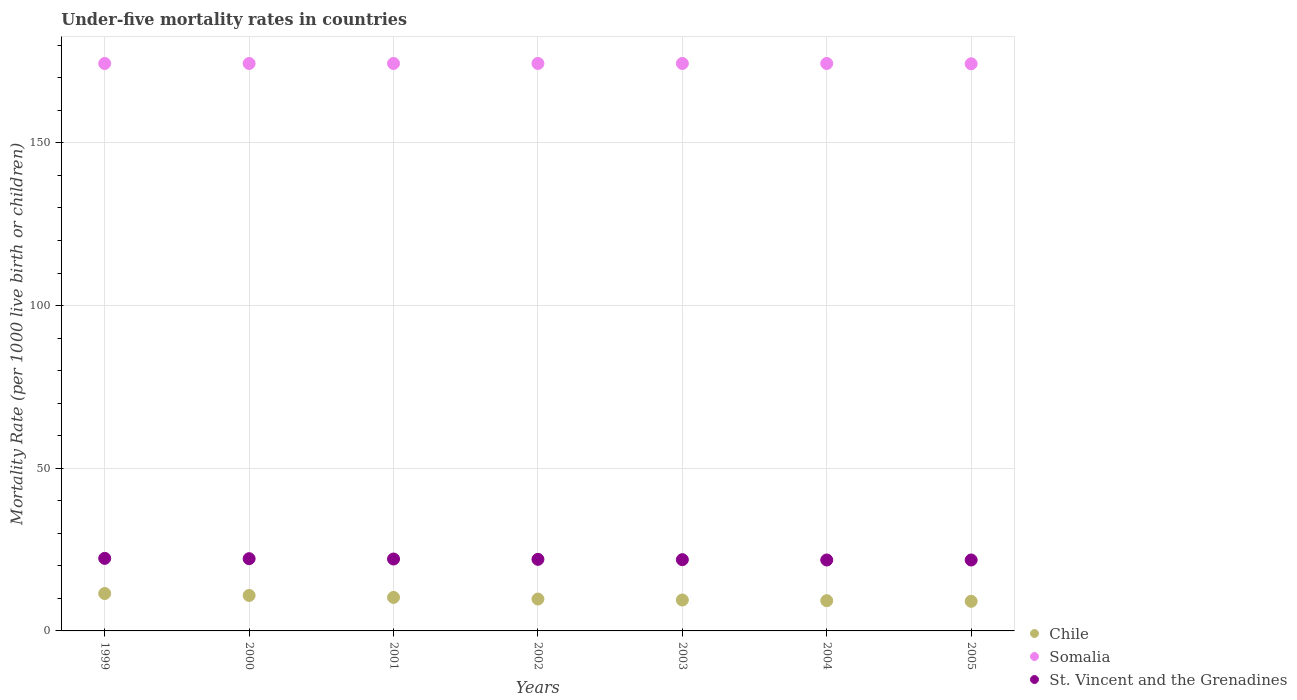How many different coloured dotlines are there?
Your answer should be compact. 3. Across all years, what is the maximum under-five mortality rate in St. Vincent and the Grenadines?
Make the answer very short. 22.3. Across all years, what is the minimum under-five mortality rate in Chile?
Offer a terse response. 9.1. In which year was the under-five mortality rate in Somalia maximum?
Make the answer very short. 1999. What is the total under-five mortality rate in St. Vincent and the Grenadines in the graph?
Give a very brief answer. 154.1. What is the difference between the under-five mortality rate in Chile in 2000 and that in 2001?
Keep it short and to the point. 0.6. What is the difference between the under-five mortality rate in Chile in 1999 and the under-five mortality rate in St. Vincent and the Grenadines in 2001?
Give a very brief answer. -10.6. What is the average under-five mortality rate in Chile per year?
Provide a succinct answer. 10.06. In the year 2004, what is the difference between the under-five mortality rate in Somalia and under-five mortality rate in St. Vincent and the Grenadines?
Offer a very short reply. 152.6. What is the difference between the highest and the second highest under-five mortality rate in St. Vincent and the Grenadines?
Give a very brief answer. 0.1. What is the difference between the highest and the lowest under-five mortality rate in Chile?
Offer a terse response. 2.4. In how many years, is the under-five mortality rate in St. Vincent and the Grenadines greater than the average under-five mortality rate in St. Vincent and the Grenadines taken over all years?
Provide a succinct answer. 3. Does the under-five mortality rate in Chile monotonically increase over the years?
Keep it short and to the point. No. Is the under-five mortality rate in Somalia strictly greater than the under-five mortality rate in Chile over the years?
Offer a very short reply. Yes. How many dotlines are there?
Make the answer very short. 3. How many years are there in the graph?
Your answer should be compact. 7. Does the graph contain grids?
Ensure brevity in your answer.  Yes. Where does the legend appear in the graph?
Offer a very short reply. Bottom right. What is the title of the graph?
Your response must be concise. Under-five mortality rates in countries. What is the label or title of the Y-axis?
Provide a succinct answer. Mortality Rate (per 1000 live birth or children). What is the Mortality Rate (per 1000 live birth or children) of Chile in 1999?
Provide a succinct answer. 11.5. What is the Mortality Rate (per 1000 live birth or children) of Somalia in 1999?
Make the answer very short. 174.4. What is the Mortality Rate (per 1000 live birth or children) of St. Vincent and the Grenadines in 1999?
Your response must be concise. 22.3. What is the Mortality Rate (per 1000 live birth or children) of Somalia in 2000?
Ensure brevity in your answer.  174.4. What is the Mortality Rate (per 1000 live birth or children) in St. Vincent and the Grenadines in 2000?
Ensure brevity in your answer.  22.2. What is the Mortality Rate (per 1000 live birth or children) in Somalia in 2001?
Offer a very short reply. 174.4. What is the Mortality Rate (per 1000 live birth or children) in St. Vincent and the Grenadines in 2001?
Your response must be concise. 22.1. What is the Mortality Rate (per 1000 live birth or children) in Chile in 2002?
Give a very brief answer. 9.8. What is the Mortality Rate (per 1000 live birth or children) in Somalia in 2002?
Your answer should be compact. 174.4. What is the Mortality Rate (per 1000 live birth or children) of St. Vincent and the Grenadines in 2002?
Your response must be concise. 22. What is the Mortality Rate (per 1000 live birth or children) in Chile in 2003?
Provide a short and direct response. 9.5. What is the Mortality Rate (per 1000 live birth or children) of Somalia in 2003?
Offer a terse response. 174.4. What is the Mortality Rate (per 1000 live birth or children) in St. Vincent and the Grenadines in 2003?
Keep it short and to the point. 21.9. What is the Mortality Rate (per 1000 live birth or children) of Chile in 2004?
Keep it short and to the point. 9.3. What is the Mortality Rate (per 1000 live birth or children) of Somalia in 2004?
Give a very brief answer. 174.4. What is the Mortality Rate (per 1000 live birth or children) of St. Vincent and the Grenadines in 2004?
Give a very brief answer. 21.8. What is the Mortality Rate (per 1000 live birth or children) of Chile in 2005?
Make the answer very short. 9.1. What is the Mortality Rate (per 1000 live birth or children) in Somalia in 2005?
Your answer should be very brief. 174.3. What is the Mortality Rate (per 1000 live birth or children) in St. Vincent and the Grenadines in 2005?
Your response must be concise. 21.8. Across all years, what is the maximum Mortality Rate (per 1000 live birth or children) of Chile?
Provide a succinct answer. 11.5. Across all years, what is the maximum Mortality Rate (per 1000 live birth or children) in Somalia?
Ensure brevity in your answer.  174.4. Across all years, what is the maximum Mortality Rate (per 1000 live birth or children) of St. Vincent and the Grenadines?
Offer a very short reply. 22.3. Across all years, what is the minimum Mortality Rate (per 1000 live birth or children) in Chile?
Provide a short and direct response. 9.1. Across all years, what is the minimum Mortality Rate (per 1000 live birth or children) of Somalia?
Offer a very short reply. 174.3. Across all years, what is the minimum Mortality Rate (per 1000 live birth or children) of St. Vincent and the Grenadines?
Offer a very short reply. 21.8. What is the total Mortality Rate (per 1000 live birth or children) of Chile in the graph?
Your answer should be very brief. 70.4. What is the total Mortality Rate (per 1000 live birth or children) of Somalia in the graph?
Your answer should be very brief. 1220.7. What is the total Mortality Rate (per 1000 live birth or children) in St. Vincent and the Grenadines in the graph?
Your response must be concise. 154.1. What is the difference between the Mortality Rate (per 1000 live birth or children) of Somalia in 1999 and that in 2000?
Offer a very short reply. 0. What is the difference between the Mortality Rate (per 1000 live birth or children) in St. Vincent and the Grenadines in 1999 and that in 2000?
Keep it short and to the point. 0.1. What is the difference between the Mortality Rate (per 1000 live birth or children) of Chile in 1999 and that in 2001?
Your response must be concise. 1.2. What is the difference between the Mortality Rate (per 1000 live birth or children) of Somalia in 1999 and that in 2002?
Give a very brief answer. 0. What is the difference between the Mortality Rate (per 1000 live birth or children) in Chile in 1999 and that in 2004?
Provide a short and direct response. 2.2. What is the difference between the Mortality Rate (per 1000 live birth or children) of Somalia in 1999 and that in 2004?
Offer a very short reply. 0. What is the difference between the Mortality Rate (per 1000 live birth or children) in St. Vincent and the Grenadines in 1999 and that in 2004?
Your response must be concise. 0.5. What is the difference between the Mortality Rate (per 1000 live birth or children) of Somalia in 1999 and that in 2005?
Your answer should be compact. 0.1. What is the difference between the Mortality Rate (per 1000 live birth or children) in St. Vincent and the Grenadines in 1999 and that in 2005?
Your answer should be compact. 0.5. What is the difference between the Mortality Rate (per 1000 live birth or children) of Chile in 2000 and that in 2001?
Give a very brief answer. 0.6. What is the difference between the Mortality Rate (per 1000 live birth or children) of St. Vincent and the Grenadines in 2000 and that in 2001?
Offer a terse response. 0.1. What is the difference between the Mortality Rate (per 1000 live birth or children) of Chile in 2000 and that in 2002?
Offer a very short reply. 1.1. What is the difference between the Mortality Rate (per 1000 live birth or children) in Somalia in 2000 and that in 2002?
Make the answer very short. 0. What is the difference between the Mortality Rate (per 1000 live birth or children) of Somalia in 2000 and that in 2003?
Offer a terse response. 0. What is the difference between the Mortality Rate (per 1000 live birth or children) of Chile in 2000 and that in 2004?
Your response must be concise. 1.6. What is the difference between the Mortality Rate (per 1000 live birth or children) in Somalia in 2000 and that in 2004?
Your response must be concise. 0. What is the difference between the Mortality Rate (per 1000 live birth or children) of St. Vincent and the Grenadines in 2000 and that in 2004?
Your answer should be very brief. 0.4. What is the difference between the Mortality Rate (per 1000 live birth or children) of Chile in 2000 and that in 2005?
Give a very brief answer. 1.8. What is the difference between the Mortality Rate (per 1000 live birth or children) of Somalia in 2000 and that in 2005?
Give a very brief answer. 0.1. What is the difference between the Mortality Rate (per 1000 live birth or children) of Somalia in 2001 and that in 2002?
Ensure brevity in your answer.  0. What is the difference between the Mortality Rate (per 1000 live birth or children) of St. Vincent and the Grenadines in 2001 and that in 2002?
Offer a very short reply. 0.1. What is the difference between the Mortality Rate (per 1000 live birth or children) in Chile in 2001 and that in 2003?
Offer a terse response. 0.8. What is the difference between the Mortality Rate (per 1000 live birth or children) in Somalia in 2001 and that in 2005?
Ensure brevity in your answer.  0.1. What is the difference between the Mortality Rate (per 1000 live birth or children) of St. Vincent and the Grenadines in 2001 and that in 2005?
Keep it short and to the point. 0.3. What is the difference between the Mortality Rate (per 1000 live birth or children) in Chile in 2002 and that in 2003?
Ensure brevity in your answer.  0.3. What is the difference between the Mortality Rate (per 1000 live birth or children) in Somalia in 2002 and that in 2003?
Ensure brevity in your answer.  0. What is the difference between the Mortality Rate (per 1000 live birth or children) in Somalia in 2002 and that in 2004?
Give a very brief answer. 0. What is the difference between the Mortality Rate (per 1000 live birth or children) in St. Vincent and the Grenadines in 2002 and that in 2004?
Keep it short and to the point. 0.2. What is the difference between the Mortality Rate (per 1000 live birth or children) of Somalia in 2002 and that in 2005?
Provide a short and direct response. 0.1. What is the difference between the Mortality Rate (per 1000 live birth or children) of St. Vincent and the Grenadines in 2002 and that in 2005?
Ensure brevity in your answer.  0.2. What is the difference between the Mortality Rate (per 1000 live birth or children) of Chile in 2003 and that in 2004?
Make the answer very short. 0.2. What is the difference between the Mortality Rate (per 1000 live birth or children) of Somalia in 2003 and that in 2004?
Make the answer very short. 0. What is the difference between the Mortality Rate (per 1000 live birth or children) of St. Vincent and the Grenadines in 2003 and that in 2004?
Provide a short and direct response. 0.1. What is the difference between the Mortality Rate (per 1000 live birth or children) of Somalia in 2003 and that in 2005?
Offer a very short reply. 0.1. What is the difference between the Mortality Rate (per 1000 live birth or children) in Chile in 2004 and that in 2005?
Offer a very short reply. 0.2. What is the difference between the Mortality Rate (per 1000 live birth or children) in St. Vincent and the Grenadines in 2004 and that in 2005?
Give a very brief answer. 0. What is the difference between the Mortality Rate (per 1000 live birth or children) in Chile in 1999 and the Mortality Rate (per 1000 live birth or children) in Somalia in 2000?
Your answer should be compact. -162.9. What is the difference between the Mortality Rate (per 1000 live birth or children) of Somalia in 1999 and the Mortality Rate (per 1000 live birth or children) of St. Vincent and the Grenadines in 2000?
Provide a short and direct response. 152.2. What is the difference between the Mortality Rate (per 1000 live birth or children) of Chile in 1999 and the Mortality Rate (per 1000 live birth or children) of Somalia in 2001?
Give a very brief answer. -162.9. What is the difference between the Mortality Rate (per 1000 live birth or children) in Somalia in 1999 and the Mortality Rate (per 1000 live birth or children) in St. Vincent and the Grenadines in 2001?
Ensure brevity in your answer.  152.3. What is the difference between the Mortality Rate (per 1000 live birth or children) of Chile in 1999 and the Mortality Rate (per 1000 live birth or children) of Somalia in 2002?
Offer a very short reply. -162.9. What is the difference between the Mortality Rate (per 1000 live birth or children) of Somalia in 1999 and the Mortality Rate (per 1000 live birth or children) of St. Vincent and the Grenadines in 2002?
Your answer should be compact. 152.4. What is the difference between the Mortality Rate (per 1000 live birth or children) of Chile in 1999 and the Mortality Rate (per 1000 live birth or children) of Somalia in 2003?
Provide a short and direct response. -162.9. What is the difference between the Mortality Rate (per 1000 live birth or children) of Somalia in 1999 and the Mortality Rate (per 1000 live birth or children) of St. Vincent and the Grenadines in 2003?
Ensure brevity in your answer.  152.5. What is the difference between the Mortality Rate (per 1000 live birth or children) in Chile in 1999 and the Mortality Rate (per 1000 live birth or children) in Somalia in 2004?
Offer a terse response. -162.9. What is the difference between the Mortality Rate (per 1000 live birth or children) in Somalia in 1999 and the Mortality Rate (per 1000 live birth or children) in St. Vincent and the Grenadines in 2004?
Offer a terse response. 152.6. What is the difference between the Mortality Rate (per 1000 live birth or children) in Chile in 1999 and the Mortality Rate (per 1000 live birth or children) in Somalia in 2005?
Give a very brief answer. -162.8. What is the difference between the Mortality Rate (per 1000 live birth or children) in Chile in 1999 and the Mortality Rate (per 1000 live birth or children) in St. Vincent and the Grenadines in 2005?
Offer a very short reply. -10.3. What is the difference between the Mortality Rate (per 1000 live birth or children) in Somalia in 1999 and the Mortality Rate (per 1000 live birth or children) in St. Vincent and the Grenadines in 2005?
Make the answer very short. 152.6. What is the difference between the Mortality Rate (per 1000 live birth or children) in Chile in 2000 and the Mortality Rate (per 1000 live birth or children) in Somalia in 2001?
Your response must be concise. -163.5. What is the difference between the Mortality Rate (per 1000 live birth or children) in Chile in 2000 and the Mortality Rate (per 1000 live birth or children) in St. Vincent and the Grenadines in 2001?
Your answer should be compact. -11.2. What is the difference between the Mortality Rate (per 1000 live birth or children) of Somalia in 2000 and the Mortality Rate (per 1000 live birth or children) of St. Vincent and the Grenadines in 2001?
Ensure brevity in your answer.  152.3. What is the difference between the Mortality Rate (per 1000 live birth or children) of Chile in 2000 and the Mortality Rate (per 1000 live birth or children) of Somalia in 2002?
Offer a terse response. -163.5. What is the difference between the Mortality Rate (per 1000 live birth or children) of Chile in 2000 and the Mortality Rate (per 1000 live birth or children) of St. Vincent and the Grenadines in 2002?
Make the answer very short. -11.1. What is the difference between the Mortality Rate (per 1000 live birth or children) of Somalia in 2000 and the Mortality Rate (per 1000 live birth or children) of St. Vincent and the Grenadines in 2002?
Offer a terse response. 152.4. What is the difference between the Mortality Rate (per 1000 live birth or children) in Chile in 2000 and the Mortality Rate (per 1000 live birth or children) in Somalia in 2003?
Your response must be concise. -163.5. What is the difference between the Mortality Rate (per 1000 live birth or children) of Chile in 2000 and the Mortality Rate (per 1000 live birth or children) of St. Vincent and the Grenadines in 2003?
Your answer should be compact. -11. What is the difference between the Mortality Rate (per 1000 live birth or children) in Somalia in 2000 and the Mortality Rate (per 1000 live birth or children) in St. Vincent and the Grenadines in 2003?
Offer a very short reply. 152.5. What is the difference between the Mortality Rate (per 1000 live birth or children) of Chile in 2000 and the Mortality Rate (per 1000 live birth or children) of Somalia in 2004?
Provide a succinct answer. -163.5. What is the difference between the Mortality Rate (per 1000 live birth or children) in Chile in 2000 and the Mortality Rate (per 1000 live birth or children) in St. Vincent and the Grenadines in 2004?
Ensure brevity in your answer.  -10.9. What is the difference between the Mortality Rate (per 1000 live birth or children) in Somalia in 2000 and the Mortality Rate (per 1000 live birth or children) in St. Vincent and the Grenadines in 2004?
Offer a terse response. 152.6. What is the difference between the Mortality Rate (per 1000 live birth or children) in Chile in 2000 and the Mortality Rate (per 1000 live birth or children) in Somalia in 2005?
Offer a very short reply. -163.4. What is the difference between the Mortality Rate (per 1000 live birth or children) in Chile in 2000 and the Mortality Rate (per 1000 live birth or children) in St. Vincent and the Grenadines in 2005?
Ensure brevity in your answer.  -10.9. What is the difference between the Mortality Rate (per 1000 live birth or children) in Somalia in 2000 and the Mortality Rate (per 1000 live birth or children) in St. Vincent and the Grenadines in 2005?
Give a very brief answer. 152.6. What is the difference between the Mortality Rate (per 1000 live birth or children) in Chile in 2001 and the Mortality Rate (per 1000 live birth or children) in Somalia in 2002?
Keep it short and to the point. -164.1. What is the difference between the Mortality Rate (per 1000 live birth or children) in Somalia in 2001 and the Mortality Rate (per 1000 live birth or children) in St. Vincent and the Grenadines in 2002?
Keep it short and to the point. 152.4. What is the difference between the Mortality Rate (per 1000 live birth or children) of Chile in 2001 and the Mortality Rate (per 1000 live birth or children) of Somalia in 2003?
Make the answer very short. -164.1. What is the difference between the Mortality Rate (per 1000 live birth or children) in Chile in 2001 and the Mortality Rate (per 1000 live birth or children) in St. Vincent and the Grenadines in 2003?
Offer a terse response. -11.6. What is the difference between the Mortality Rate (per 1000 live birth or children) of Somalia in 2001 and the Mortality Rate (per 1000 live birth or children) of St. Vincent and the Grenadines in 2003?
Your answer should be very brief. 152.5. What is the difference between the Mortality Rate (per 1000 live birth or children) in Chile in 2001 and the Mortality Rate (per 1000 live birth or children) in Somalia in 2004?
Keep it short and to the point. -164.1. What is the difference between the Mortality Rate (per 1000 live birth or children) of Somalia in 2001 and the Mortality Rate (per 1000 live birth or children) of St. Vincent and the Grenadines in 2004?
Give a very brief answer. 152.6. What is the difference between the Mortality Rate (per 1000 live birth or children) of Chile in 2001 and the Mortality Rate (per 1000 live birth or children) of Somalia in 2005?
Provide a short and direct response. -164. What is the difference between the Mortality Rate (per 1000 live birth or children) of Somalia in 2001 and the Mortality Rate (per 1000 live birth or children) of St. Vincent and the Grenadines in 2005?
Keep it short and to the point. 152.6. What is the difference between the Mortality Rate (per 1000 live birth or children) in Chile in 2002 and the Mortality Rate (per 1000 live birth or children) in Somalia in 2003?
Your answer should be very brief. -164.6. What is the difference between the Mortality Rate (per 1000 live birth or children) in Chile in 2002 and the Mortality Rate (per 1000 live birth or children) in St. Vincent and the Grenadines in 2003?
Your response must be concise. -12.1. What is the difference between the Mortality Rate (per 1000 live birth or children) in Somalia in 2002 and the Mortality Rate (per 1000 live birth or children) in St. Vincent and the Grenadines in 2003?
Provide a succinct answer. 152.5. What is the difference between the Mortality Rate (per 1000 live birth or children) in Chile in 2002 and the Mortality Rate (per 1000 live birth or children) in Somalia in 2004?
Keep it short and to the point. -164.6. What is the difference between the Mortality Rate (per 1000 live birth or children) in Somalia in 2002 and the Mortality Rate (per 1000 live birth or children) in St. Vincent and the Grenadines in 2004?
Provide a short and direct response. 152.6. What is the difference between the Mortality Rate (per 1000 live birth or children) in Chile in 2002 and the Mortality Rate (per 1000 live birth or children) in Somalia in 2005?
Provide a succinct answer. -164.5. What is the difference between the Mortality Rate (per 1000 live birth or children) of Chile in 2002 and the Mortality Rate (per 1000 live birth or children) of St. Vincent and the Grenadines in 2005?
Make the answer very short. -12. What is the difference between the Mortality Rate (per 1000 live birth or children) in Somalia in 2002 and the Mortality Rate (per 1000 live birth or children) in St. Vincent and the Grenadines in 2005?
Provide a short and direct response. 152.6. What is the difference between the Mortality Rate (per 1000 live birth or children) of Chile in 2003 and the Mortality Rate (per 1000 live birth or children) of Somalia in 2004?
Your answer should be compact. -164.9. What is the difference between the Mortality Rate (per 1000 live birth or children) in Somalia in 2003 and the Mortality Rate (per 1000 live birth or children) in St. Vincent and the Grenadines in 2004?
Keep it short and to the point. 152.6. What is the difference between the Mortality Rate (per 1000 live birth or children) in Chile in 2003 and the Mortality Rate (per 1000 live birth or children) in Somalia in 2005?
Offer a very short reply. -164.8. What is the difference between the Mortality Rate (per 1000 live birth or children) of Chile in 2003 and the Mortality Rate (per 1000 live birth or children) of St. Vincent and the Grenadines in 2005?
Ensure brevity in your answer.  -12.3. What is the difference between the Mortality Rate (per 1000 live birth or children) in Somalia in 2003 and the Mortality Rate (per 1000 live birth or children) in St. Vincent and the Grenadines in 2005?
Offer a terse response. 152.6. What is the difference between the Mortality Rate (per 1000 live birth or children) in Chile in 2004 and the Mortality Rate (per 1000 live birth or children) in Somalia in 2005?
Your response must be concise. -165. What is the difference between the Mortality Rate (per 1000 live birth or children) in Somalia in 2004 and the Mortality Rate (per 1000 live birth or children) in St. Vincent and the Grenadines in 2005?
Provide a succinct answer. 152.6. What is the average Mortality Rate (per 1000 live birth or children) in Chile per year?
Make the answer very short. 10.06. What is the average Mortality Rate (per 1000 live birth or children) of Somalia per year?
Offer a terse response. 174.39. What is the average Mortality Rate (per 1000 live birth or children) of St. Vincent and the Grenadines per year?
Your answer should be very brief. 22.01. In the year 1999, what is the difference between the Mortality Rate (per 1000 live birth or children) in Chile and Mortality Rate (per 1000 live birth or children) in Somalia?
Keep it short and to the point. -162.9. In the year 1999, what is the difference between the Mortality Rate (per 1000 live birth or children) in Chile and Mortality Rate (per 1000 live birth or children) in St. Vincent and the Grenadines?
Your answer should be compact. -10.8. In the year 1999, what is the difference between the Mortality Rate (per 1000 live birth or children) in Somalia and Mortality Rate (per 1000 live birth or children) in St. Vincent and the Grenadines?
Your answer should be compact. 152.1. In the year 2000, what is the difference between the Mortality Rate (per 1000 live birth or children) in Chile and Mortality Rate (per 1000 live birth or children) in Somalia?
Ensure brevity in your answer.  -163.5. In the year 2000, what is the difference between the Mortality Rate (per 1000 live birth or children) of Chile and Mortality Rate (per 1000 live birth or children) of St. Vincent and the Grenadines?
Your answer should be compact. -11.3. In the year 2000, what is the difference between the Mortality Rate (per 1000 live birth or children) in Somalia and Mortality Rate (per 1000 live birth or children) in St. Vincent and the Grenadines?
Keep it short and to the point. 152.2. In the year 2001, what is the difference between the Mortality Rate (per 1000 live birth or children) of Chile and Mortality Rate (per 1000 live birth or children) of Somalia?
Make the answer very short. -164.1. In the year 2001, what is the difference between the Mortality Rate (per 1000 live birth or children) of Chile and Mortality Rate (per 1000 live birth or children) of St. Vincent and the Grenadines?
Keep it short and to the point. -11.8. In the year 2001, what is the difference between the Mortality Rate (per 1000 live birth or children) in Somalia and Mortality Rate (per 1000 live birth or children) in St. Vincent and the Grenadines?
Offer a very short reply. 152.3. In the year 2002, what is the difference between the Mortality Rate (per 1000 live birth or children) of Chile and Mortality Rate (per 1000 live birth or children) of Somalia?
Give a very brief answer. -164.6. In the year 2002, what is the difference between the Mortality Rate (per 1000 live birth or children) of Somalia and Mortality Rate (per 1000 live birth or children) of St. Vincent and the Grenadines?
Make the answer very short. 152.4. In the year 2003, what is the difference between the Mortality Rate (per 1000 live birth or children) in Chile and Mortality Rate (per 1000 live birth or children) in Somalia?
Your answer should be compact. -164.9. In the year 2003, what is the difference between the Mortality Rate (per 1000 live birth or children) in Chile and Mortality Rate (per 1000 live birth or children) in St. Vincent and the Grenadines?
Keep it short and to the point. -12.4. In the year 2003, what is the difference between the Mortality Rate (per 1000 live birth or children) in Somalia and Mortality Rate (per 1000 live birth or children) in St. Vincent and the Grenadines?
Your answer should be compact. 152.5. In the year 2004, what is the difference between the Mortality Rate (per 1000 live birth or children) of Chile and Mortality Rate (per 1000 live birth or children) of Somalia?
Make the answer very short. -165.1. In the year 2004, what is the difference between the Mortality Rate (per 1000 live birth or children) of Chile and Mortality Rate (per 1000 live birth or children) of St. Vincent and the Grenadines?
Make the answer very short. -12.5. In the year 2004, what is the difference between the Mortality Rate (per 1000 live birth or children) in Somalia and Mortality Rate (per 1000 live birth or children) in St. Vincent and the Grenadines?
Provide a succinct answer. 152.6. In the year 2005, what is the difference between the Mortality Rate (per 1000 live birth or children) in Chile and Mortality Rate (per 1000 live birth or children) in Somalia?
Your response must be concise. -165.2. In the year 2005, what is the difference between the Mortality Rate (per 1000 live birth or children) of Somalia and Mortality Rate (per 1000 live birth or children) of St. Vincent and the Grenadines?
Keep it short and to the point. 152.5. What is the ratio of the Mortality Rate (per 1000 live birth or children) of Chile in 1999 to that in 2000?
Provide a short and direct response. 1.05. What is the ratio of the Mortality Rate (per 1000 live birth or children) in St. Vincent and the Grenadines in 1999 to that in 2000?
Give a very brief answer. 1. What is the ratio of the Mortality Rate (per 1000 live birth or children) in Chile in 1999 to that in 2001?
Your answer should be very brief. 1.12. What is the ratio of the Mortality Rate (per 1000 live birth or children) in Somalia in 1999 to that in 2001?
Offer a very short reply. 1. What is the ratio of the Mortality Rate (per 1000 live birth or children) of Chile in 1999 to that in 2002?
Keep it short and to the point. 1.17. What is the ratio of the Mortality Rate (per 1000 live birth or children) of St. Vincent and the Grenadines in 1999 to that in 2002?
Give a very brief answer. 1.01. What is the ratio of the Mortality Rate (per 1000 live birth or children) in Chile in 1999 to that in 2003?
Make the answer very short. 1.21. What is the ratio of the Mortality Rate (per 1000 live birth or children) in Somalia in 1999 to that in 2003?
Your response must be concise. 1. What is the ratio of the Mortality Rate (per 1000 live birth or children) of St. Vincent and the Grenadines in 1999 to that in 2003?
Your answer should be compact. 1.02. What is the ratio of the Mortality Rate (per 1000 live birth or children) of Chile in 1999 to that in 2004?
Your answer should be very brief. 1.24. What is the ratio of the Mortality Rate (per 1000 live birth or children) of Somalia in 1999 to that in 2004?
Offer a terse response. 1. What is the ratio of the Mortality Rate (per 1000 live birth or children) in St. Vincent and the Grenadines in 1999 to that in 2004?
Your answer should be very brief. 1.02. What is the ratio of the Mortality Rate (per 1000 live birth or children) of Chile in 1999 to that in 2005?
Provide a short and direct response. 1.26. What is the ratio of the Mortality Rate (per 1000 live birth or children) of Somalia in 1999 to that in 2005?
Offer a terse response. 1. What is the ratio of the Mortality Rate (per 1000 live birth or children) in St. Vincent and the Grenadines in 1999 to that in 2005?
Keep it short and to the point. 1.02. What is the ratio of the Mortality Rate (per 1000 live birth or children) of Chile in 2000 to that in 2001?
Provide a short and direct response. 1.06. What is the ratio of the Mortality Rate (per 1000 live birth or children) of Somalia in 2000 to that in 2001?
Keep it short and to the point. 1. What is the ratio of the Mortality Rate (per 1000 live birth or children) in St. Vincent and the Grenadines in 2000 to that in 2001?
Your answer should be compact. 1. What is the ratio of the Mortality Rate (per 1000 live birth or children) of Chile in 2000 to that in 2002?
Your answer should be very brief. 1.11. What is the ratio of the Mortality Rate (per 1000 live birth or children) in Somalia in 2000 to that in 2002?
Offer a very short reply. 1. What is the ratio of the Mortality Rate (per 1000 live birth or children) of St. Vincent and the Grenadines in 2000 to that in 2002?
Give a very brief answer. 1.01. What is the ratio of the Mortality Rate (per 1000 live birth or children) in Chile in 2000 to that in 2003?
Offer a terse response. 1.15. What is the ratio of the Mortality Rate (per 1000 live birth or children) of St. Vincent and the Grenadines in 2000 to that in 2003?
Your response must be concise. 1.01. What is the ratio of the Mortality Rate (per 1000 live birth or children) in Chile in 2000 to that in 2004?
Ensure brevity in your answer.  1.17. What is the ratio of the Mortality Rate (per 1000 live birth or children) in St. Vincent and the Grenadines in 2000 to that in 2004?
Your answer should be compact. 1.02. What is the ratio of the Mortality Rate (per 1000 live birth or children) of Chile in 2000 to that in 2005?
Provide a short and direct response. 1.2. What is the ratio of the Mortality Rate (per 1000 live birth or children) in St. Vincent and the Grenadines in 2000 to that in 2005?
Offer a terse response. 1.02. What is the ratio of the Mortality Rate (per 1000 live birth or children) in Chile in 2001 to that in 2002?
Provide a short and direct response. 1.05. What is the ratio of the Mortality Rate (per 1000 live birth or children) of Somalia in 2001 to that in 2002?
Provide a short and direct response. 1. What is the ratio of the Mortality Rate (per 1000 live birth or children) of Chile in 2001 to that in 2003?
Provide a short and direct response. 1.08. What is the ratio of the Mortality Rate (per 1000 live birth or children) in Somalia in 2001 to that in 2003?
Provide a succinct answer. 1. What is the ratio of the Mortality Rate (per 1000 live birth or children) in St. Vincent and the Grenadines in 2001 to that in 2003?
Provide a short and direct response. 1.01. What is the ratio of the Mortality Rate (per 1000 live birth or children) in Chile in 2001 to that in 2004?
Provide a succinct answer. 1.11. What is the ratio of the Mortality Rate (per 1000 live birth or children) in St. Vincent and the Grenadines in 2001 to that in 2004?
Ensure brevity in your answer.  1.01. What is the ratio of the Mortality Rate (per 1000 live birth or children) in Chile in 2001 to that in 2005?
Provide a succinct answer. 1.13. What is the ratio of the Mortality Rate (per 1000 live birth or children) of Somalia in 2001 to that in 2005?
Give a very brief answer. 1. What is the ratio of the Mortality Rate (per 1000 live birth or children) in St. Vincent and the Grenadines in 2001 to that in 2005?
Your response must be concise. 1.01. What is the ratio of the Mortality Rate (per 1000 live birth or children) in Chile in 2002 to that in 2003?
Your response must be concise. 1.03. What is the ratio of the Mortality Rate (per 1000 live birth or children) in Somalia in 2002 to that in 2003?
Your answer should be very brief. 1. What is the ratio of the Mortality Rate (per 1000 live birth or children) in Chile in 2002 to that in 2004?
Provide a short and direct response. 1.05. What is the ratio of the Mortality Rate (per 1000 live birth or children) in St. Vincent and the Grenadines in 2002 to that in 2004?
Make the answer very short. 1.01. What is the ratio of the Mortality Rate (per 1000 live birth or children) of Chile in 2002 to that in 2005?
Your answer should be compact. 1.08. What is the ratio of the Mortality Rate (per 1000 live birth or children) in St. Vincent and the Grenadines in 2002 to that in 2005?
Offer a very short reply. 1.01. What is the ratio of the Mortality Rate (per 1000 live birth or children) of Chile in 2003 to that in 2004?
Your answer should be compact. 1.02. What is the ratio of the Mortality Rate (per 1000 live birth or children) of Chile in 2003 to that in 2005?
Your response must be concise. 1.04. What is the ratio of the Mortality Rate (per 1000 live birth or children) of Somalia in 2003 to that in 2005?
Your response must be concise. 1. What is the ratio of the Mortality Rate (per 1000 live birth or children) of Chile in 2004 to that in 2005?
Keep it short and to the point. 1.02. What is the ratio of the Mortality Rate (per 1000 live birth or children) in Somalia in 2004 to that in 2005?
Your answer should be compact. 1. What is the ratio of the Mortality Rate (per 1000 live birth or children) of St. Vincent and the Grenadines in 2004 to that in 2005?
Your answer should be compact. 1. What is the difference between the highest and the second highest Mortality Rate (per 1000 live birth or children) of Somalia?
Offer a terse response. 0. What is the difference between the highest and the lowest Mortality Rate (per 1000 live birth or children) of Chile?
Offer a terse response. 2.4. What is the difference between the highest and the lowest Mortality Rate (per 1000 live birth or children) of Somalia?
Your answer should be compact. 0.1. What is the difference between the highest and the lowest Mortality Rate (per 1000 live birth or children) of St. Vincent and the Grenadines?
Offer a very short reply. 0.5. 